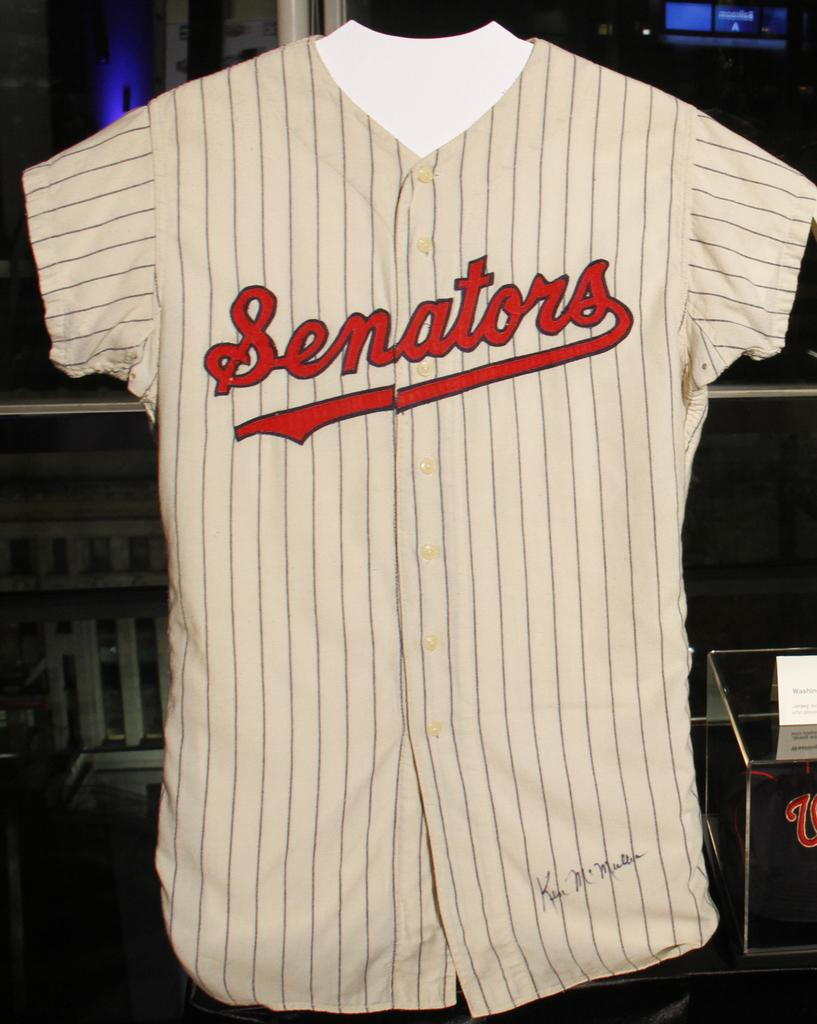<image>
Offer a succinct explanation of the picture presented. Baseball jersy that ha Senators across middle and signed by Ken McMullen 